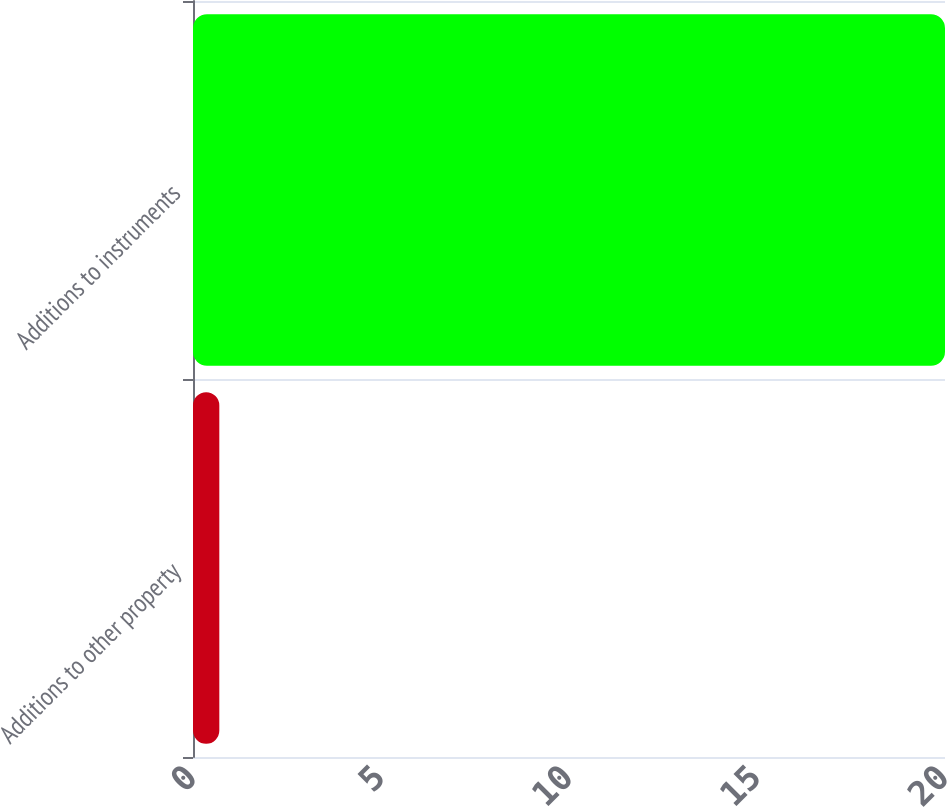Convert chart to OTSL. <chart><loc_0><loc_0><loc_500><loc_500><bar_chart><fcel>Additions to other property<fcel>Additions to instruments<nl><fcel>0.7<fcel>20<nl></chart> 